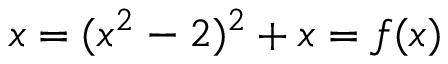<formula> <loc_0><loc_0><loc_500><loc_500>x = ( x ^ { 2 } - 2 ) ^ { 2 } + x = f ( x )</formula> 